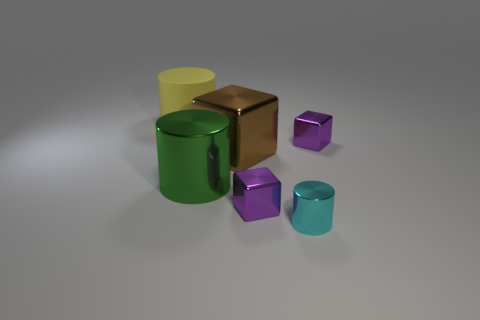How many green metal objects are the same shape as the tiny cyan thing?
Give a very brief answer. 1. Is the shape of the purple object that is right of the tiny cyan metallic thing the same as  the big brown metal object?
Ensure brevity in your answer.  Yes. There is a tiny cube that is in front of the large block; what is its color?
Ensure brevity in your answer.  Purple. There is a metal cube that is the same size as the yellow cylinder; what color is it?
Ensure brevity in your answer.  Brown. Do the cyan thing and the large brown object have the same shape?
Your response must be concise. No. What is the small purple thing that is behind the large green cylinder made of?
Offer a terse response. Metal. What is the color of the small metal cylinder?
Your answer should be compact. Cyan. Do the yellow cylinder behind the cyan cylinder and the metallic cylinder left of the big brown metal object have the same size?
Offer a very short reply. Yes. What is the size of the object that is both to the right of the big green object and behind the large brown metallic block?
Provide a succinct answer. Small. What is the color of the other rubber object that is the same shape as the large green object?
Your answer should be very brief. Yellow. 